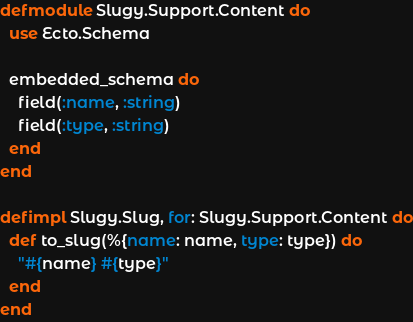<code> <loc_0><loc_0><loc_500><loc_500><_Elixir_>defmodule Slugy.Support.Content do
  use Ecto.Schema

  embedded_schema do
    field(:name, :string)
    field(:type, :string)
  end
end

defimpl Slugy.Slug, for: Slugy.Support.Content do
  def to_slug(%{name: name, type: type}) do
    "#{name} #{type}"
  end
end
</code> 